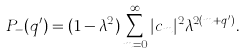Convert formula to latex. <formula><loc_0><loc_0><loc_500><loc_500>P _ { - } ( q ^ { \prime } ) = ( 1 - \lambda ^ { 2 } ) \sum _ { m = 0 } ^ { \infty } | c _ { m } | ^ { 2 } \lambda ^ { 2 ( m + q ^ { \prime } ) } .</formula> 